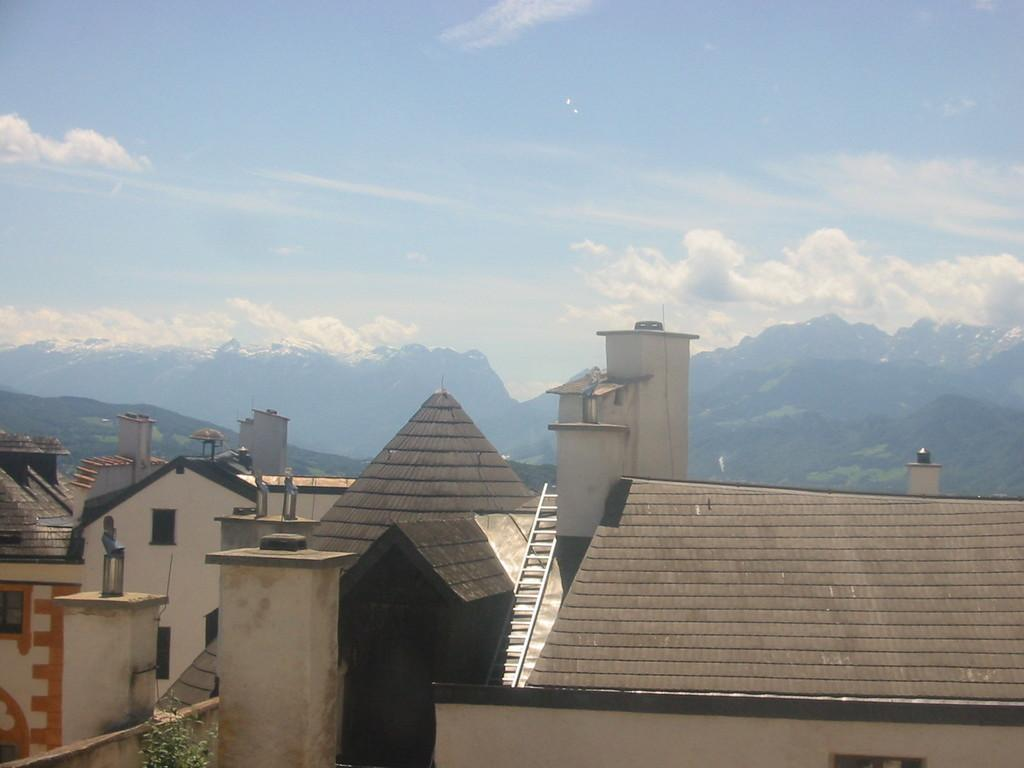What type of structures are present in the image? There are buildings in the image. What feature do the buildings have? The buildings have windows. What object can be seen near the buildings? There is a ladder in the image. What type of vegetation is present in the image? There is a plant in the image. What natural feature is visible in the background? Mountains are visible in the image. How would you describe the sky in the image? The sky is cloudy and pale blue. What type of tin can be seen being used for education in the image? There is no tin or educational activity present in the image. 